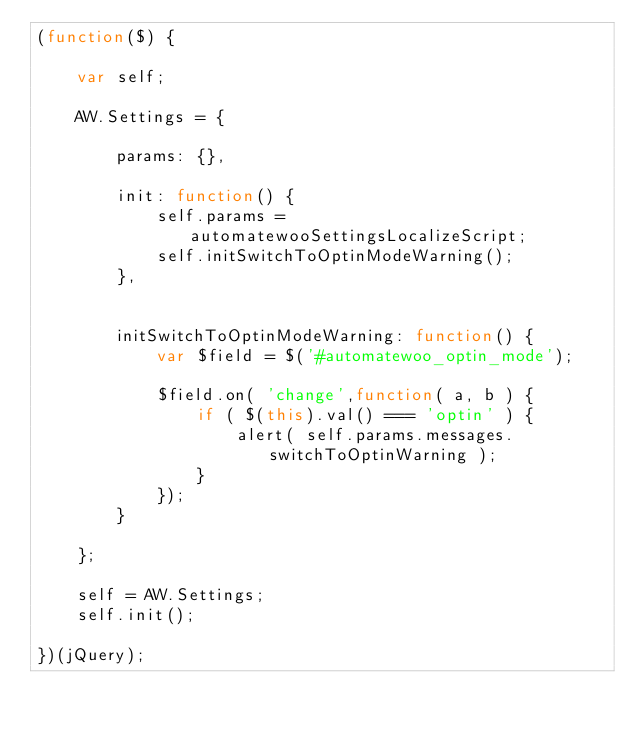Convert code to text. <code><loc_0><loc_0><loc_500><loc_500><_JavaScript_>(function($) {

    var self;

    AW.Settings = {

        params: {},

        init: function() {
            self.params = automatewooSettingsLocalizeScript;
            self.initSwitchToOptinModeWarning();
        },


        initSwitchToOptinModeWarning: function() {
            var $field = $('#automatewoo_optin_mode');

            $field.on( 'change',function( a, b ) {
                if ( $(this).val() === 'optin' ) {
                    alert( self.params.messages.switchToOptinWarning );
                }
            });
        }

    };

    self = AW.Settings;
    self.init();

})(jQuery);
</code> 